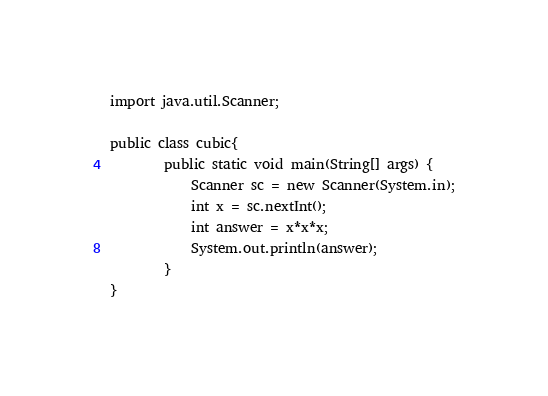<code> <loc_0><loc_0><loc_500><loc_500><_Java_>import java.util.Scanner;

public class cubic{
		public static void main(String[] args) {
			Scanner sc = new Scanner(System.in);
			int x = sc.nextInt();
			int answer = x*x*x;
			System.out.println(answer);
		}
}</code> 